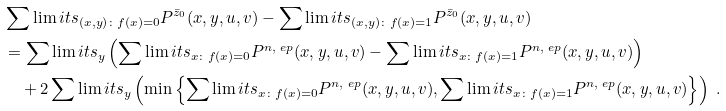Convert formula to latex. <formula><loc_0><loc_0><loc_500><loc_500>& \sum \lim i t s _ { { ( x , y ) } \colon f ( { x } ) = 0 } P ^ { \bar { z } _ { 0 } } ( { { x , y } , { u , v } } ) - \sum \lim i t s _ { { ( x , y ) } \colon f ( { x } ) = 1 } P ^ { \bar { z } _ { 0 } } ( { { x , y } , { u , v } } ) \\ & = \sum \lim i t s _ { y } \left ( \sum \lim i t s _ { { x } \colon f ( { x } ) = 0 } P ^ { n , \ e p } ( { { x , y } , { u , v } } ) - \sum \lim i t s _ { { x } \colon f ( { x } ) = 1 } P ^ { n , \ e p } ( { { x , y } , { u , v } } ) \right ) \\ & \quad + 2 \sum \lim i t s _ { y } \left ( \min \left \{ \sum \lim i t s _ { { x } \colon f ( { x } ) = 0 } P ^ { n , \ e p } ( { { x , y } , { u , v } } ) , \sum \lim i t s _ { { x } \colon f ( { x } ) = 1 } P ^ { n , \ e p } ( { { x , y } , { u , v } } ) \right \} \right ) \ .</formula> 